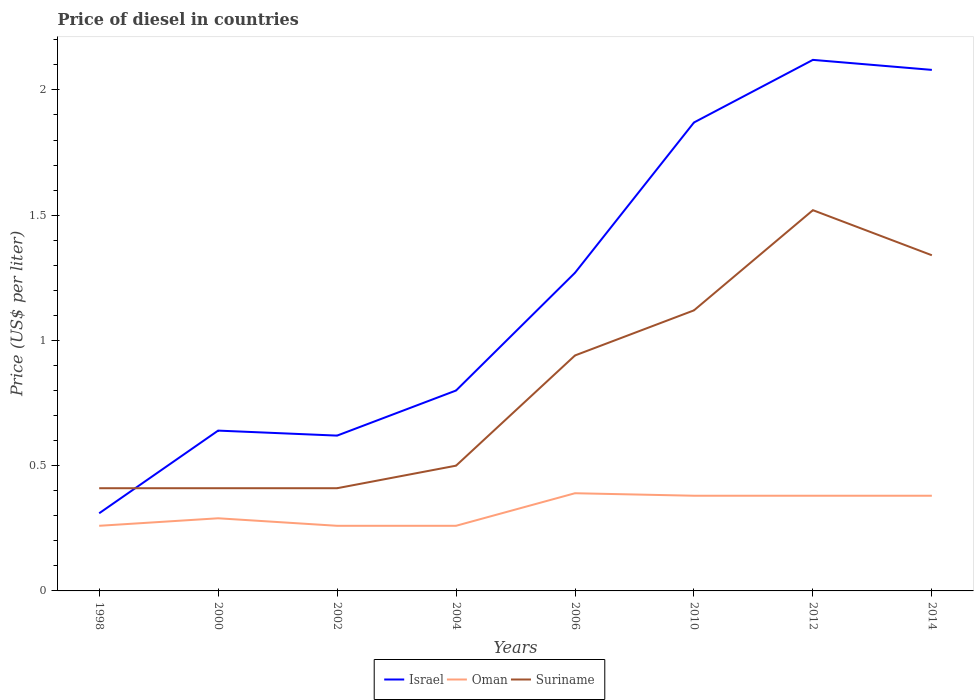How many different coloured lines are there?
Offer a very short reply. 3. Does the line corresponding to Israel intersect with the line corresponding to Suriname?
Provide a succinct answer. Yes. Across all years, what is the maximum price of diesel in Israel?
Offer a very short reply. 0.31. What is the total price of diesel in Israel in the graph?
Provide a succinct answer. -1.46. What is the difference between the highest and the second highest price of diesel in Suriname?
Provide a short and direct response. 1.11. What is the difference between the highest and the lowest price of diesel in Israel?
Offer a very short reply. 4. Is the price of diesel in Suriname strictly greater than the price of diesel in Oman over the years?
Offer a very short reply. No. How many lines are there?
Keep it short and to the point. 3. How many years are there in the graph?
Your response must be concise. 8. What is the difference between two consecutive major ticks on the Y-axis?
Your answer should be compact. 0.5. Does the graph contain any zero values?
Make the answer very short. No. How are the legend labels stacked?
Make the answer very short. Horizontal. What is the title of the graph?
Ensure brevity in your answer.  Price of diesel in countries. What is the label or title of the X-axis?
Your answer should be very brief. Years. What is the label or title of the Y-axis?
Keep it short and to the point. Price (US$ per liter). What is the Price (US$ per liter) of Israel in 1998?
Offer a terse response. 0.31. What is the Price (US$ per liter) in Oman in 1998?
Give a very brief answer. 0.26. What is the Price (US$ per liter) of Suriname in 1998?
Provide a short and direct response. 0.41. What is the Price (US$ per liter) in Israel in 2000?
Offer a very short reply. 0.64. What is the Price (US$ per liter) of Oman in 2000?
Offer a very short reply. 0.29. What is the Price (US$ per liter) of Suriname in 2000?
Offer a very short reply. 0.41. What is the Price (US$ per liter) of Israel in 2002?
Give a very brief answer. 0.62. What is the Price (US$ per liter) in Oman in 2002?
Give a very brief answer. 0.26. What is the Price (US$ per liter) of Suriname in 2002?
Offer a terse response. 0.41. What is the Price (US$ per liter) in Israel in 2004?
Provide a succinct answer. 0.8. What is the Price (US$ per liter) of Oman in 2004?
Provide a short and direct response. 0.26. What is the Price (US$ per liter) of Israel in 2006?
Provide a short and direct response. 1.27. What is the Price (US$ per liter) of Oman in 2006?
Your answer should be compact. 0.39. What is the Price (US$ per liter) of Suriname in 2006?
Keep it short and to the point. 0.94. What is the Price (US$ per liter) in Israel in 2010?
Your answer should be very brief. 1.87. What is the Price (US$ per liter) of Oman in 2010?
Offer a very short reply. 0.38. What is the Price (US$ per liter) of Suriname in 2010?
Your answer should be very brief. 1.12. What is the Price (US$ per liter) of Israel in 2012?
Your answer should be very brief. 2.12. What is the Price (US$ per liter) of Oman in 2012?
Your answer should be very brief. 0.38. What is the Price (US$ per liter) of Suriname in 2012?
Keep it short and to the point. 1.52. What is the Price (US$ per liter) in Israel in 2014?
Your answer should be compact. 2.08. What is the Price (US$ per liter) in Oman in 2014?
Keep it short and to the point. 0.38. What is the Price (US$ per liter) of Suriname in 2014?
Your answer should be very brief. 1.34. Across all years, what is the maximum Price (US$ per liter) in Israel?
Your answer should be compact. 2.12. Across all years, what is the maximum Price (US$ per liter) of Oman?
Your answer should be compact. 0.39. Across all years, what is the maximum Price (US$ per liter) in Suriname?
Provide a short and direct response. 1.52. Across all years, what is the minimum Price (US$ per liter) in Israel?
Make the answer very short. 0.31. Across all years, what is the minimum Price (US$ per liter) of Oman?
Provide a short and direct response. 0.26. Across all years, what is the minimum Price (US$ per liter) of Suriname?
Your answer should be very brief. 0.41. What is the total Price (US$ per liter) in Israel in the graph?
Provide a succinct answer. 9.71. What is the total Price (US$ per liter) in Oman in the graph?
Offer a very short reply. 2.6. What is the total Price (US$ per liter) of Suriname in the graph?
Provide a short and direct response. 6.65. What is the difference between the Price (US$ per liter) in Israel in 1998 and that in 2000?
Provide a short and direct response. -0.33. What is the difference between the Price (US$ per liter) of Oman in 1998 and that in 2000?
Make the answer very short. -0.03. What is the difference between the Price (US$ per liter) of Israel in 1998 and that in 2002?
Offer a very short reply. -0.31. What is the difference between the Price (US$ per liter) in Suriname in 1998 and that in 2002?
Ensure brevity in your answer.  0. What is the difference between the Price (US$ per liter) of Israel in 1998 and that in 2004?
Your answer should be very brief. -0.49. What is the difference between the Price (US$ per liter) in Oman in 1998 and that in 2004?
Ensure brevity in your answer.  0. What is the difference between the Price (US$ per liter) of Suriname in 1998 and that in 2004?
Your response must be concise. -0.09. What is the difference between the Price (US$ per liter) of Israel in 1998 and that in 2006?
Provide a short and direct response. -0.96. What is the difference between the Price (US$ per liter) in Oman in 1998 and that in 2006?
Ensure brevity in your answer.  -0.13. What is the difference between the Price (US$ per liter) of Suriname in 1998 and that in 2006?
Provide a short and direct response. -0.53. What is the difference between the Price (US$ per liter) in Israel in 1998 and that in 2010?
Keep it short and to the point. -1.56. What is the difference between the Price (US$ per liter) of Oman in 1998 and that in 2010?
Provide a succinct answer. -0.12. What is the difference between the Price (US$ per liter) in Suriname in 1998 and that in 2010?
Your answer should be very brief. -0.71. What is the difference between the Price (US$ per liter) of Israel in 1998 and that in 2012?
Your response must be concise. -1.81. What is the difference between the Price (US$ per liter) of Oman in 1998 and that in 2012?
Your answer should be very brief. -0.12. What is the difference between the Price (US$ per liter) of Suriname in 1998 and that in 2012?
Your answer should be very brief. -1.11. What is the difference between the Price (US$ per liter) of Israel in 1998 and that in 2014?
Ensure brevity in your answer.  -1.77. What is the difference between the Price (US$ per liter) in Oman in 1998 and that in 2014?
Give a very brief answer. -0.12. What is the difference between the Price (US$ per liter) of Suriname in 1998 and that in 2014?
Provide a short and direct response. -0.93. What is the difference between the Price (US$ per liter) of Oman in 2000 and that in 2002?
Make the answer very short. 0.03. What is the difference between the Price (US$ per liter) in Suriname in 2000 and that in 2002?
Provide a short and direct response. 0. What is the difference between the Price (US$ per liter) in Israel in 2000 and that in 2004?
Provide a short and direct response. -0.16. What is the difference between the Price (US$ per liter) in Oman in 2000 and that in 2004?
Give a very brief answer. 0.03. What is the difference between the Price (US$ per liter) in Suriname in 2000 and that in 2004?
Keep it short and to the point. -0.09. What is the difference between the Price (US$ per liter) in Israel in 2000 and that in 2006?
Offer a terse response. -0.63. What is the difference between the Price (US$ per liter) in Suriname in 2000 and that in 2006?
Keep it short and to the point. -0.53. What is the difference between the Price (US$ per liter) of Israel in 2000 and that in 2010?
Make the answer very short. -1.23. What is the difference between the Price (US$ per liter) in Oman in 2000 and that in 2010?
Make the answer very short. -0.09. What is the difference between the Price (US$ per liter) of Suriname in 2000 and that in 2010?
Offer a very short reply. -0.71. What is the difference between the Price (US$ per liter) of Israel in 2000 and that in 2012?
Your response must be concise. -1.48. What is the difference between the Price (US$ per liter) in Oman in 2000 and that in 2012?
Your answer should be compact. -0.09. What is the difference between the Price (US$ per liter) of Suriname in 2000 and that in 2012?
Keep it short and to the point. -1.11. What is the difference between the Price (US$ per liter) in Israel in 2000 and that in 2014?
Offer a very short reply. -1.44. What is the difference between the Price (US$ per liter) of Oman in 2000 and that in 2014?
Give a very brief answer. -0.09. What is the difference between the Price (US$ per liter) of Suriname in 2000 and that in 2014?
Make the answer very short. -0.93. What is the difference between the Price (US$ per liter) in Israel in 2002 and that in 2004?
Make the answer very short. -0.18. What is the difference between the Price (US$ per liter) in Suriname in 2002 and that in 2004?
Your response must be concise. -0.09. What is the difference between the Price (US$ per liter) of Israel in 2002 and that in 2006?
Your answer should be very brief. -0.65. What is the difference between the Price (US$ per liter) of Oman in 2002 and that in 2006?
Give a very brief answer. -0.13. What is the difference between the Price (US$ per liter) of Suriname in 2002 and that in 2006?
Your answer should be very brief. -0.53. What is the difference between the Price (US$ per liter) in Israel in 2002 and that in 2010?
Offer a very short reply. -1.25. What is the difference between the Price (US$ per liter) in Oman in 2002 and that in 2010?
Keep it short and to the point. -0.12. What is the difference between the Price (US$ per liter) in Suriname in 2002 and that in 2010?
Offer a terse response. -0.71. What is the difference between the Price (US$ per liter) in Israel in 2002 and that in 2012?
Give a very brief answer. -1.5. What is the difference between the Price (US$ per liter) of Oman in 2002 and that in 2012?
Provide a short and direct response. -0.12. What is the difference between the Price (US$ per liter) of Suriname in 2002 and that in 2012?
Your answer should be compact. -1.11. What is the difference between the Price (US$ per liter) in Israel in 2002 and that in 2014?
Offer a very short reply. -1.46. What is the difference between the Price (US$ per liter) of Oman in 2002 and that in 2014?
Your answer should be very brief. -0.12. What is the difference between the Price (US$ per liter) in Suriname in 2002 and that in 2014?
Your answer should be very brief. -0.93. What is the difference between the Price (US$ per liter) in Israel in 2004 and that in 2006?
Offer a very short reply. -0.47. What is the difference between the Price (US$ per liter) of Oman in 2004 and that in 2006?
Offer a terse response. -0.13. What is the difference between the Price (US$ per liter) in Suriname in 2004 and that in 2006?
Provide a short and direct response. -0.44. What is the difference between the Price (US$ per liter) in Israel in 2004 and that in 2010?
Your answer should be very brief. -1.07. What is the difference between the Price (US$ per liter) of Oman in 2004 and that in 2010?
Give a very brief answer. -0.12. What is the difference between the Price (US$ per liter) of Suriname in 2004 and that in 2010?
Your answer should be very brief. -0.62. What is the difference between the Price (US$ per liter) of Israel in 2004 and that in 2012?
Offer a terse response. -1.32. What is the difference between the Price (US$ per liter) in Oman in 2004 and that in 2012?
Give a very brief answer. -0.12. What is the difference between the Price (US$ per liter) of Suriname in 2004 and that in 2012?
Offer a very short reply. -1.02. What is the difference between the Price (US$ per liter) of Israel in 2004 and that in 2014?
Offer a very short reply. -1.28. What is the difference between the Price (US$ per liter) of Oman in 2004 and that in 2014?
Provide a short and direct response. -0.12. What is the difference between the Price (US$ per liter) of Suriname in 2004 and that in 2014?
Ensure brevity in your answer.  -0.84. What is the difference between the Price (US$ per liter) of Suriname in 2006 and that in 2010?
Keep it short and to the point. -0.18. What is the difference between the Price (US$ per liter) of Israel in 2006 and that in 2012?
Provide a short and direct response. -0.85. What is the difference between the Price (US$ per liter) of Oman in 2006 and that in 2012?
Your response must be concise. 0.01. What is the difference between the Price (US$ per liter) in Suriname in 2006 and that in 2012?
Give a very brief answer. -0.58. What is the difference between the Price (US$ per liter) of Israel in 2006 and that in 2014?
Ensure brevity in your answer.  -0.81. What is the difference between the Price (US$ per liter) of Oman in 2006 and that in 2014?
Keep it short and to the point. 0.01. What is the difference between the Price (US$ per liter) in Suriname in 2010 and that in 2012?
Offer a terse response. -0.4. What is the difference between the Price (US$ per liter) of Israel in 2010 and that in 2014?
Your response must be concise. -0.21. What is the difference between the Price (US$ per liter) in Suriname in 2010 and that in 2014?
Provide a short and direct response. -0.22. What is the difference between the Price (US$ per liter) of Israel in 2012 and that in 2014?
Offer a very short reply. 0.04. What is the difference between the Price (US$ per liter) of Oman in 2012 and that in 2014?
Offer a terse response. 0. What is the difference between the Price (US$ per liter) of Suriname in 2012 and that in 2014?
Ensure brevity in your answer.  0.18. What is the difference between the Price (US$ per liter) in Israel in 1998 and the Price (US$ per liter) in Oman in 2002?
Provide a succinct answer. 0.05. What is the difference between the Price (US$ per liter) of Israel in 1998 and the Price (US$ per liter) of Suriname in 2004?
Your answer should be compact. -0.19. What is the difference between the Price (US$ per liter) of Oman in 1998 and the Price (US$ per liter) of Suriname in 2004?
Your answer should be compact. -0.24. What is the difference between the Price (US$ per liter) in Israel in 1998 and the Price (US$ per liter) in Oman in 2006?
Provide a short and direct response. -0.08. What is the difference between the Price (US$ per liter) in Israel in 1998 and the Price (US$ per liter) in Suriname in 2006?
Make the answer very short. -0.63. What is the difference between the Price (US$ per liter) of Oman in 1998 and the Price (US$ per liter) of Suriname in 2006?
Provide a short and direct response. -0.68. What is the difference between the Price (US$ per liter) in Israel in 1998 and the Price (US$ per liter) in Oman in 2010?
Provide a succinct answer. -0.07. What is the difference between the Price (US$ per liter) in Israel in 1998 and the Price (US$ per liter) in Suriname in 2010?
Your answer should be compact. -0.81. What is the difference between the Price (US$ per liter) of Oman in 1998 and the Price (US$ per liter) of Suriname in 2010?
Your response must be concise. -0.86. What is the difference between the Price (US$ per liter) of Israel in 1998 and the Price (US$ per liter) of Oman in 2012?
Your answer should be very brief. -0.07. What is the difference between the Price (US$ per liter) in Israel in 1998 and the Price (US$ per liter) in Suriname in 2012?
Ensure brevity in your answer.  -1.21. What is the difference between the Price (US$ per liter) of Oman in 1998 and the Price (US$ per liter) of Suriname in 2012?
Give a very brief answer. -1.26. What is the difference between the Price (US$ per liter) of Israel in 1998 and the Price (US$ per liter) of Oman in 2014?
Your answer should be compact. -0.07. What is the difference between the Price (US$ per liter) of Israel in 1998 and the Price (US$ per liter) of Suriname in 2014?
Provide a succinct answer. -1.03. What is the difference between the Price (US$ per liter) in Oman in 1998 and the Price (US$ per liter) in Suriname in 2014?
Provide a short and direct response. -1.08. What is the difference between the Price (US$ per liter) in Israel in 2000 and the Price (US$ per liter) in Oman in 2002?
Your answer should be compact. 0.38. What is the difference between the Price (US$ per liter) of Israel in 2000 and the Price (US$ per liter) of Suriname in 2002?
Your response must be concise. 0.23. What is the difference between the Price (US$ per liter) of Oman in 2000 and the Price (US$ per liter) of Suriname in 2002?
Your answer should be very brief. -0.12. What is the difference between the Price (US$ per liter) of Israel in 2000 and the Price (US$ per liter) of Oman in 2004?
Your answer should be very brief. 0.38. What is the difference between the Price (US$ per liter) of Israel in 2000 and the Price (US$ per liter) of Suriname in 2004?
Your answer should be very brief. 0.14. What is the difference between the Price (US$ per liter) in Oman in 2000 and the Price (US$ per liter) in Suriname in 2004?
Ensure brevity in your answer.  -0.21. What is the difference between the Price (US$ per liter) in Oman in 2000 and the Price (US$ per liter) in Suriname in 2006?
Offer a terse response. -0.65. What is the difference between the Price (US$ per liter) in Israel in 2000 and the Price (US$ per liter) in Oman in 2010?
Provide a succinct answer. 0.26. What is the difference between the Price (US$ per liter) of Israel in 2000 and the Price (US$ per liter) of Suriname in 2010?
Make the answer very short. -0.48. What is the difference between the Price (US$ per liter) of Oman in 2000 and the Price (US$ per liter) of Suriname in 2010?
Offer a terse response. -0.83. What is the difference between the Price (US$ per liter) of Israel in 2000 and the Price (US$ per liter) of Oman in 2012?
Provide a succinct answer. 0.26. What is the difference between the Price (US$ per liter) of Israel in 2000 and the Price (US$ per liter) of Suriname in 2012?
Offer a very short reply. -0.88. What is the difference between the Price (US$ per liter) in Oman in 2000 and the Price (US$ per liter) in Suriname in 2012?
Your answer should be very brief. -1.23. What is the difference between the Price (US$ per liter) in Israel in 2000 and the Price (US$ per liter) in Oman in 2014?
Your response must be concise. 0.26. What is the difference between the Price (US$ per liter) of Oman in 2000 and the Price (US$ per liter) of Suriname in 2014?
Offer a very short reply. -1.05. What is the difference between the Price (US$ per liter) in Israel in 2002 and the Price (US$ per liter) in Oman in 2004?
Offer a very short reply. 0.36. What is the difference between the Price (US$ per liter) in Israel in 2002 and the Price (US$ per liter) in Suriname in 2004?
Keep it short and to the point. 0.12. What is the difference between the Price (US$ per liter) in Oman in 2002 and the Price (US$ per liter) in Suriname in 2004?
Offer a very short reply. -0.24. What is the difference between the Price (US$ per liter) of Israel in 2002 and the Price (US$ per liter) of Oman in 2006?
Offer a terse response. 0.23. What is the difference between the Price (US$ per liter) in Israel in 2002 and the Price (US$ per liter) in Suriname in 2006?
Give a very brief answer. -0.32. What is the difference between the Price (US$ per liter) in Oman in 2002 and the Price (US$ per liter) in Suriname in 2006?
Keep it short and to the point. -0.68. What is the difference between the Price (US$ per liter) of Israel in 2002 and the Price (US$ per liter) of Oman in 2010?
Your answer should be very brief. 0.24. What is the difference between the Price (US$ per liter) of Oman in 2002 and the Price (US$ per liter) of Suriname in 2010?
Make the answer very short. -0.86. What is the difference between the Price (US$ per liter) of Israel in 2002 and the Price (US$ per liter) of Oman in 2012?
Keep it short and to the point. 0.24. What is the difference between the Price (US$ per liter) of Israel in 2002 and the Price (US$ per liter) of Suriname in 2012?
Provide a succinct answer. -0.9. What is the difference between the Price (US$ per liter) of Oman in 2002 and the Price (US$ per liter) of Suriname in 2012?
Offer a terse response. -1.26. What is the difference between the Price (US$ per liter) of Israel in 2002 and the Price (US$ per liter) of Oman in 2014?
Your answer should be compact. 0.24. What is the difference between the Price (US$ per liter) in Israel in 2002 and the Price (US$ per liter) in Suriname in 2014?
Provide a short and direct response. -0.72. What is the difference between the Price (US$ per liter) in Oman in 2002 and the Price (US$ per liter) in Suriname in 2014?
Your answer should be compact. -1.08. What is the difference between the Price (US$ per liter) of Israel in 2004 and the Price (US$ per liter) of Oman in 2006?
Offer a very short reply. 0.41. What is the difference between the Price (US$ per liter) of Israel in 2004 and the Price (US$ per liter) of Suriname in 2006?
Your response must be concise. -0.14. What is the difference between the Price (US$ per liter) of Oman in 2004 and the Price (US$ per liter) of Suriname in 2006?
Provide a short and direct response. -0.68. What is the difference between the Price (US$ per liter) of Israel in 2004 and the Price (US$ per liter) of Oman in 2010?
Ensure brevity in your answer.  0.42. What is the difference between the Price (US$ per liter) of Israel in 2004 and the Price (US$ per liter) of Suriname in 2010?
Keep it short and to the point. -0.32. What is the difference between the Price (US$ per liter) of Oman in 2004 and the Price (US$ per liter) of Suriname in 2010?
Give a very brief answer. -0.86. What is the difference between the Price (US$ per liter) in Israel in 2004 and the Price (US$ per liter) in Oman in 2012?
Provide a short and direct response. 0.42. What is the difference between the Price (US$ per liter) of Israel in 2004 and the Price (US$ per liter) of Suriname in 2012?
Offer a terse response. -0.72. What is the difference between the Price (US$ per liter) in Oman in 2004 and the Price (US$ per liter) in Suriname in 2012?
Provide a short and direct response. -1.26. What is the difference between the Price (US$ per liter) of Israel in 2004 and the Price (US$ per liter) of Oman in 2014?
Provide a short and direct response. 0.42. What is the difference between the Price (US$ per liter) of Israel in 2004 and the Price (US$ per liter) of Suriname in 2014?
Make the answer very short. -0.54. What is the difference between the Price (US$ per liter) of Oman in 2004 and the Price (US$ per liter) of Suriname in 2014?
Offer a terse response. -1.08. What is the difference between the Price (US$ per liter) in Israel in 2006 and the Price (US$ per liter) in Oman in 2010?
Your response must be concise. 0.89. What is the difference between the Price (US$ per liter) in Oman in 2006 and the Price (US$ per liter) in Suriname in 2010?
Keep it short and to the point. -0.73. What is the difference between the Price (US$ per liter) in Israel in 2006 and the Price (US$ per liter) in Oman in 2012?
Make the answer very short. 0.89. What is the difference between the Price (US$ per liter) of Israel in 2006 and the Price (US$ per liter) of Suriname in 2012?
Offer a terse response. -0.25. What is the difference between the Price (US$ per liter) in Oman in 2006 and the Price (US$ per liter) in Suriname in 2012?
Ensure brevity in your answer.  -1.13. What is the difference between the Price (US$ per liter) in Israel in 2006 and the Price (US$ per liter) in Oman in 2014?
Offer a terse response. 0.89. What is the difference between the Price (US$ per liter) in Israel in 2006 and the Price (US$ per liter) in Suriname in 2014?
Keep it short and to the point. -0.07. What is the difference between the Price (US$ per liter) in Oman in 2006 and the Price (US$ per liter) in Suriname in 2014?
Your answer should be very brief. -0.95. What is the difference between the Price (US$ per liter) in Israel in 2010 and the Price (US$ per liter) in Oman in 2012?
Your answer should be very brief. 1.49. What is the difference between the Price (US$ per liter) of Israel in 2010 and the Price (US$ per liter) of Suriname in 2012?
Offer a very short reply. 0.35. What is the difference between the Price (US$ per liter) in Oman in 2010 and the Price (US$ per liter) in Suriname in 2012?
Offer a terse response. -1.14. What is the difference between the Price (US$ per liter) of Israel in 2010 and the Price (US$ per liter) of Oman in 2014?
Your answer should be compact. 1.49. What is the difference between the Price (US$ per liter) of Israel in 2010 and the Price (US$ per liter) of Suriname in 2014?
Make the answer very short. 0.53. What is the difference between the Price (US$ per liter) in Oman in 2010 and the Price (US$ per liter) in Suriname in 2014?
Your answer should be very brief. -0.96. What is the difference between the Price (US$ per liter) in Israel in 2012 and the Price (US$ per liter) in Oman in 2014?
Your answer should be very brief. 1.74. What is the difference between the Price (US$ per liter) in Israel in 2012 and the Price (US$ per liter) in Suriname in 2014?
Make the answer very short. 0.78. What is the difference between the Price (US$ per liter) in Oman in 2012 and the Price (US$ per liter) in Suriname in 2014?
Offer a very short reply. -0.96. What is the average Price (US$ per liter) of Israel per year?
Keep it short and to the point. 1.21. What is the average Price (US$ per liter) of Oman per year?
Keep it short and to the point. 0.33. What is the average Price (US$ per liter) of Suriname per year?
Your answer should be very brief. 0.83. In the year 2000, what is the difference between the Price (US$ per liter) in Israel and Price (US$ per liter) in Oman?
Your answer should be very brief. 0.35. In the year 2000, what is the difference between the Price (US$ per liter) in Israel and Price (US$ per liter) in Suriname?
Your answer should be compact. 0.23. In the year 2000, what is the difference between the Price (US$ per liter) of Oman and Price (US$ per liter) of Suriname?
Offer a terse response. -0.12. In the year 2002, what is the difference between the Price (US$ per liter) in Israel and Price (US$ per liter) in Oman?
Offer a very short reply. 0.36. In the year 2002, what is the difference between the Price (US$ per liter) in Israel and Price (US$ per liter) in Suriname?
Give a very brief answer. 0.21. In the year 2002, what is the difference between the Price (US$ per liter) in Oman and Price (US$ per liter) in Suriname?
Give a very brief answer. -0.15. In the year 2004, what is the difference between the Price (US$ per liter) in Israel and Price (US$ per liter) in Oman?
Ensure brevity in your answer.  0.54. In the year 2004, what is the difference between the Price (US$ per liter) of Israel and Price (US$ per liter) of Suriname?
Give a very brief answer. 0.3. In the year 2004, what is the difference between the Price (US$ per liter) of Oman and Price (US$ per liter) of Suriname?
Provide a short and direct response. -0.24. In the year 2006, what is the difference between the Price (US$ per liter) in Israel and Price (US$ per liter) in Oman?
Your answer should be very brief. 0.88. In the year 2006, what is the difference between the Price (US$ per liter) of Israel and Price (US$ per liter) of Suriname?
Keep it short and to the point. 0.33. In the year 2006, what is the difference between the Price (US$ per liter) of Oman and Price (US$ per liter) of Suriname?
Your response must be concise. -0.55. In the year 2010, what is the difference between the Price (US$ per liter) of Israel and Price (US$ per liter) of Oman?
Your response must be concise. 1.49. In the year 2010, what is the difference between the Price (US$ per liter) in Israel and Price (US$ per liter) in Suriname?
Your answer should be compact. 0.75. In the year 2010, what is the difference between the Price (US$ per liter) of Oman and Price (US$ per liter) of Suriname?
Give a very brief answer. -0.74. In the year 2012, what is the difference between the Price (US$ per liter) in Israel and Price (US$ per liter) in Oman?
Keep it short and to the point. 1.74. In the year 2012, what is the difference between the Price (US$ per liter) of Israel and Price (US$ per liter) of Suriname?
Provide a succinct answer. 0.6. In the year 2012, what is the difference between the Price (US$ per liter) of Oman and Price (US$ per liter) of Suriname?
Keep it short and to the point. -1.14. In the year 2014, what is the difference between the Price (US$ per liter) of Israel and Price (US$ per liter) of Suriname?
Your answer should be very brief. 0.74. In the year 2014, what is the difference between the Price (US$ per liter) of Oman and Price (US$ per liter) of Suriname?
Make the answer very short. -0.96. What is the ratio of the Price (US$ per liter) of Israel in 1998 to that in 2000?
Offer a very short reply. 0.48. What is the ratio of the Price (US$ per liter) in Oman in 1998 to that in 2000?
Keep it short and to the point. 0.9. What is the ratio of the Price (US$ per liter) in Israel in 1998 to that in 2002?
Ensure brevity in your answer.  0.5. What is the ratio of the Price (US$ per liter) of Israel in 1998 to that in 2004?
Give a very brief answer. 0.39. What is the ratio of the Price (US$ per liter) of Oman in 1998 to that in 2004?
Your answer should be compact. 1. What is the ratio of the Price (US$ per liter) in Suriname in 1998 to that in 2004?
Make the answer very short. 0.82. What is the ratio of the Price (US$ per liter) of Israel in 1998 to that in 2006?
Your answer should be very brief. 0.24. What is the ratio of the Price (US$ per liter) of Suriname in 1998 to that in 2006?
Offer a terse response. 0.44. What is the ratio of the Price (US$ per liter) in Israel in 1998 to that in 2010?
Offer a very short reply. 0.17. What is the ratio of the Price (US$ per liter) of Oman in 1998 to that in 2010?
Offer a very short reply. 0.68. What is the ratio of the Price (US$ per liter) of Suriname in 1998 to that in 2010?
Ensure brevity in your answer.  0.37. What is the ratio of the Price (US$ per liter) in Israel in 1998 to that in 2012?
Offer a very short reply. 0.15. What is the ratio of the Price (US$ per liter) in Oman in 1998 to that in 2012?
Provide a short and direct response. 0.68. What is the ratio of the Price (US$ per liter) in Suriname in 1998 to that in 2012?
Ensure brevity in your answer.  0.27. What is the ratio of the Price (US$ per liter) of Israel in 1998 to that in 2014?
Offer a very short reply. 0.15. What is the ratio of the Price (US$ per liter) in Oman in 1998 to that in 2014?
Make the answer very short. 0.68. What is the ratio of the Price (US$ per liter) in Suriname in 1998 to that in 2014?
Provide a short and direct response. 0.31. What is the ratio of the Price (US$ per liter) in Israel in 2000 to that in 2002?
Ensure brevity in your answer.  1.03. What is the ratio of the Price (US$ per liter) of Oman in 2000 to that in 2002?
Offer a very short reply. 1.12. What is the ratio of the Price (US$ per liter) in Israel in 2000 to that in 2004?
Offer a terse response. 0.8. What is the ratio of the Price (US$ per liter) in Oman in 2000 to that in 2004?
Make the answer very short. 1.12. What is the ratio of the Price (US$ per liter) of Suriname in 2000 to that in 2004?
Your answer should be compact. 0.82. What is the ratio of the Price (US$ per liter) in Israel in 2000 to that in 2006?
Offer a terse response. 0.5. What is the ratio of the Price (US$ per liter) in Oman in 2000 to that in 2006?
Your answer should be compact. 0.74. What is the ratio of the Price (US$ per liter) of Suriname in 2000 to that in 2006?
Your answer should be very brief. 0.44. What is the ratio of the Price (US$ per liter) in Israel in 2000 to that in 2010?
Offer a terse response. 0.34. What is the ratio of the Price (US$ per liter) of Oman in 2000 to that in 2010?
Your response must be concise. 0.76. What is the ratio of the Price (US$ per liter) in Suriname in 2000 to that in 2010?
Offer a very short reply. 0.37. What is the ratio of the Price (US$ per liter) of Israel in 2000 to that in 2012?
Your answer should be very brief. 0.3. What is the ratio of the Price (US$ per liter) in Oman in 2000 to that in 2012?
Your response must be concise. 0.76. What is the ratio of the Price (US$ per liter) of Suriname in 2000 to that in 2012?
Give a very brief answer. 0.27. What is the ratio of the Price (US$ per liter) of Israel in 2000 to that in 2014?
Give a very brief answer. 0.31. What is the ratio of the Price (US$ per liter) in Oman in 2000 to that in 2014?
Your answer should be very brief. 0.76. What is the ratio of the Price (US$ per liter) of Suriname in 2000 to that in 2014?
Your response must be concise. 0.31. What is the ratio of the Price (US$ per liter) of Israel in 2002 to that in 2004?
Keep it short and to the point. 0.78. What is the ratio of the Price (US$ per liter) in Suriname in 2002 to that in 2004?
Keep it short and to the point. 0.82. What is the ratio of the Price (US$ per liter) in Israel in 2002 to that in 2006?
Your response must be concise. 0.49. What is the ratio of the Price (US$ per liter) in Suriname in 2002 to that in 2006?
Provide a short and direct response. 0.44. What is the ratio of the Price (US$ per liter) of Israel in 2002 to that in 2010?
Ensure brevity in your answer.  0.33. What is the ratio of the Price (US$ per liter) of Oman in 2002 to that in 2010?
Ensure brevity in your answer.  0.68. What is the ratio of the Price (US$ per liter) of Suriname in 2002 to that in 2010?
Your answer should be compact. 0.37. What is the ratio of the Price (US$ per liter) of Israel in 2002 to that in 2012?
Ensure brevity in your answer.  0.29. What is the ratio of the Price (US$ per liter) of Oman in 2002 to that in 2012?
Your response must be concise. 0.68. What is the ratio of the Price (US$ per liter) in Suriname in 2002 to that in 2012?
Make the answer very short. 0.27. What is the ratio of the Price (US$ per liter) in Israel in 2002 to that in 2014?
Provide a short and direct response. 0.3. What is the ratio of the Price (US$ per liter) of Oman in 2002 to that in 2014?
Provide a succinct answer. 0.68. What is the ratio of the Price (US$ per liter) of Suriname in 2002 to that in 2014?
Provide a succinct answer. 0.31. What is the ratio of the Price (US$ per liter) in Israel in 2004 to that in 2006?
Your response must be concise. 0.63. What is the ratio of the Price (US$ per liter) of Suriname in 2004 to that in 2006?
Your answer should be very brief. 0.53. What is the ratio of the Price (US$ per liter) in Israel in 2004 to that in 2010?
Offer a terse response. 0.43. What is the ratio of the Price (US$ per liter) in Oman in 2004 to that in 2010?
Your answer should be compact. 0.68. What is the ratio of the Price (US$ per liter) of Suriname in 2004 to that in 2010?
Provide a succinct answer. 0.45. What is the ratio of the Price (US$ per liter) of Israel in 2004 to that in 2012?
Provide a succinct answer. 0.38. What is the ratio of the Price (US$ per liter) in Oman in 2004 to that in 2012?
Give a very brief answer. 0.68. What is the ratio of the Price (US$ per liter) of Suriname in 2004 to that in 2012?
Make the answer very short. 0.33. What is the ratio of the Price (US$ per liter) in Israel in 2004 to that in 2014?
Offer a terse response. 0.38. What is the ratio of the Price (US$ per liter) in Oman in 2004 to that in 2014?
Your answer should be very brief. 0.68. What is the ratio of the Price (US$ per liter) of Suriname in 2004 to that in 2014?
Your response must be concise. 0.37. What is the ratio of the Price (US$ per liter) of Israel in 2006 to that in 2010?
Your answer should be compact. 0.68. What is the ratio of the Price (US$ per liter) in Oman in 2006 to that in 2010?
Your answer should be very brief. 1.03. What is the ratio of the Price (US$ per liter) in Suriname in 2006 to that in 2010?
Offer a terse response. 0.84. What is the ratio of the Price (US$ per liter) of Israel in 2006 to that in 2012?
Provide a short and direct response. 0.6. What is the ratio of the Price (US$ per liter) in Oman in 2006 to that in 2012?
Give a very brief answer. 1.03. What is the ratio of the Price (US$ per liter) of Suriname in 2006 to that in 2012?
Provide a succinct answer. 0.62. What is the ratio of the Price (US$ per liter) of Israel in 2006 to that in 2014?
Offer a very short reply. 0.61. What is the ratio of the Price (US$ per liter) of Oman in 2006 to that in 2014?
Provide a succinct answer. 1.03. What is the ratio of the Price (US$ per liter) of Suriname in 2006 to that in 2014?
Offer a terse response. 0.7. What is the ratio of the Price (US$ per liter) of Israel in 2010 to that in 2012?
Offer a very short reply. 0.88. What is the ratio of the Price (US$ per liter) of Oman in 2010 to that in 2012?
Make the answer very short. 1. What is the ratio of the Price (US$ per liter) of Suriname in 2010 to that in 2012?
Your answer should be compact. 0.74. What is the ratio of the Price (US$ per liter) in Israel in 2010 to that in 2014?
Ensure brevity in your answer.  0.9. What is the ratio of the Price (US$ per liter) in Oman in 2010 to that in 2014?
Your response must be concise. 1. What is the ratio of the Price (US$ per liter) in Suriname in 2010 to that in 2014?
Offer a terse response. 0.84. What is the ratio of the Price (US$ per liter) of Israel in 2012 to that in 2014?
Provide a succinct answer. 1.02. What is the ratio of the Price (US$ per liter) of Oman in 2012 to that in 2014?
Provide a succinct answer. 1. What is the ratio of the Price (US$ per liter) of Suriname in 2012 to that in 2014?
Provide a short and direct response. 1.13. What is the difference between the highest and the second highest Price (US$ per liter) in Israel?
Your answer should be very brief. 0.04. What is the difference between the highest and the second highest Price (US$ per liter) in Suriname?
Keep it short and to the point. 0.18. What is the difference between the highest and the lowest Price (US$ per liter) in Israel?
Offer a terse response. 1.81. What is the difference between the highest and the lowest Price (US$ per liter) in Oman?
Ensure brevity in your answer.  0.13. What is the difference between the highest and the lowest Price (US$ per liter) of Suriname?
Offer a very short reply. 1.11. 